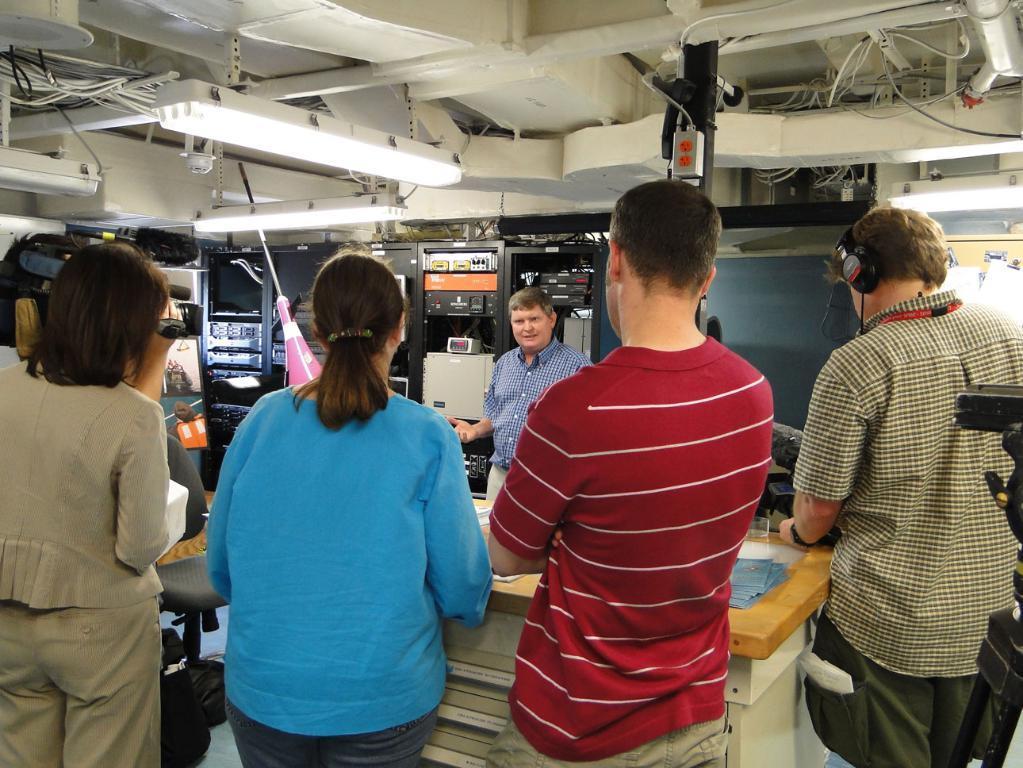How would you summarize this image in a sentence or two? Here we can see few persons. This is a table. In the background we can see few objects and there are lights. 